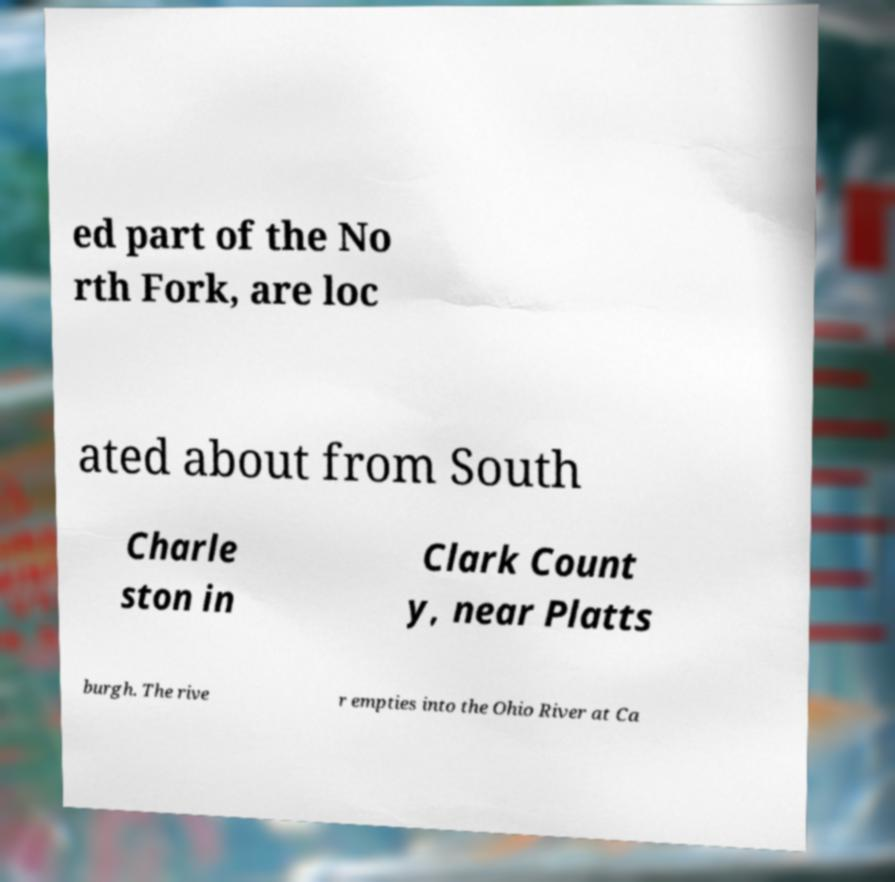Please identify and transcribe the text found in this image. ed part of the No rth Fork, are loc ated about from South Charle ston in Clark Count y, near Platts burgh. The rive r empties into the Ohio River at Ca 